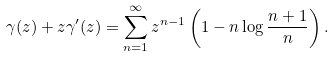Convert formula to latex. <formula><loc_0><loc_0><loc_500><loc_500>\gamma ( z ) + z \gamma ^ { \prime } ( z ) = \sum _ { n = 1 } ^ { \infty } z ^ { n - 1 } \left ( 1 - n \log \frac { n + 1 } { n } \right ) .</formula> 